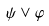<formula> <loc_0><loc_0><loc_500><loc_500>\psi \vee \varphi</formula> 